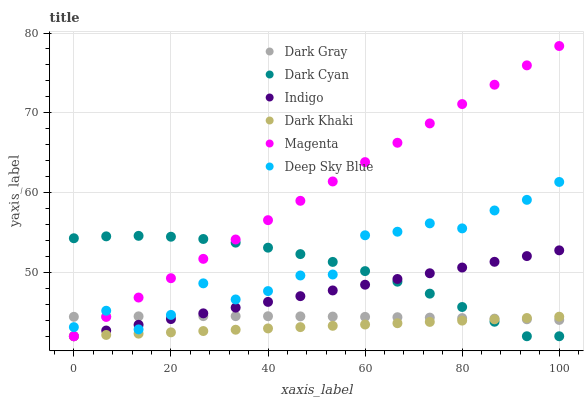Does Dark Khaki have the minimum area under the curve?
Answer yes or no. Yes. Does Magenta have the maximum area under the curve?
Answer yes or no. Yes. Does Indigo have the minimum area under the curve?
Answer yes or no. No. Does Indigo have the maximum area under the curve?
Answer yes or no. No. Is Dark Khaki the smoothest?
Answer yes or no. Yes. Is Deep Sky Blue the roughest?
Answer yes or no. Yes. Is Indigo the smoothest?
Answer yes or no. No. Is Indigo the roughest?
Answer yes or no. No. Does Dark Khaki have the lowest value?
Answer yes or no. Yes. Does Dark Gray have the lowest value?
Answer yes or no. No. Does Magenta have the highest value?
Answer yes or no. Yes. Does Indigo have the highest value?
Answer yes or no. No. Is Dark Khaki less than Deep Sky Blue?
Answer yes or no. Yes. Is Deep Sky Blue greater than Dark Khaki?
Answer yes or no. Yes. Does Dark Khaki intersect Magenta?
Answer yes or no. Yes. Is Dark Khaki less than Magenta?
Answer yes or no. No. Is Dark Khaki greater than Magenta?
Answer yes or no. No. Does Dark Khaki intersect Deep Sky Blue?
Answer yes or no. No. 